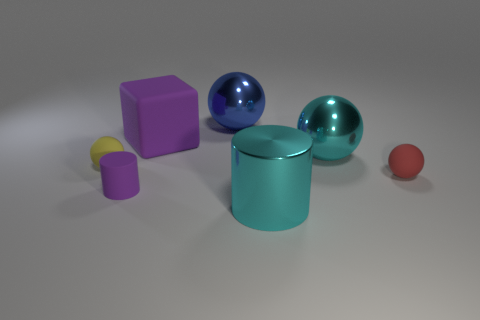Is there anything else that is the same shape as the large matte thing?
Provide a short and direct response. No. What number of metal objects are in front of the tiny ball to the left of the purple thing behind the yellow object?
Your answer should be compact. 1. The thing that is both in front of the purple cube and behind the tiny yellow matte thing is made of what material?
Your response must be concise. Metal. The large matte block is what color?
Your answer should be very brief. Purple. Is the number of big balls in front of the tiny yellow thing greater than the number of purple matte cubes left of the large blue metallic ball?
Provide a short and direct response. No. The metal sphere that is to the right of the large cyan metal cylinder is what color?
Make the answer very short. Cyan. Do the cylinder that is right of the rubber cube and the matte block behind the purple cylinder have the same size?
Provide a succinct answer. Yes. What number of things are large spheres or big purple rubber objects?
Your answer should be compact. 3. The big sphere behind the big cyan metallic object that is behind the tiny red sphere is made of what material?
Give a very brief answer. Metal. How many other purple objects have the same shape as the big purple rubber object?
Offer a very short reply. 0. 